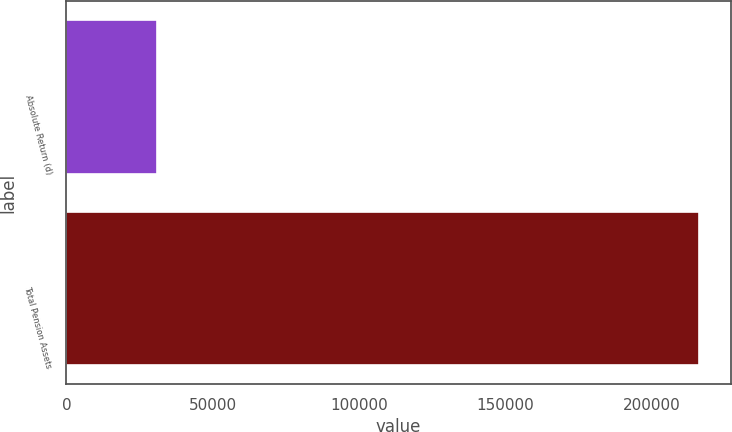<chart> <loc_0><loc_0><loc_500><loc_500><bar_chart><fcel>Absolute Return (d)<fcel>Total Pension Assets<nl><fcel>30816<fcel>216105<nl></chart> 